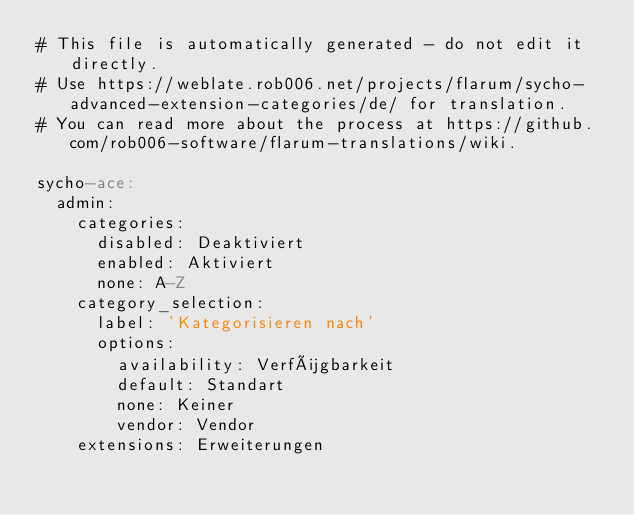<code> <loc_0><loc_0><loc_500><loc_500><_YAML_># This file is automatically generated - do not edit it directly.
# Use https://weblate.rob006.net/projects/flarum/sycho-advanced-extension-categories/de/ for translation.
# You can read more about the process at https://github.com/rob006-software/flarum-translations/wiki.

sycho-ace:
  admin:
    categories:
      disabled: Deaktiviert
      enabled: Aktiviert
      none: A-Z
    category_selection:
      label: 'Kategorisieren nach'
      options:
        availability: Verfügbarkeit
        default: Standart
        none: Keiner
        vendor: Vendor
    extensions: Erweiterungen
</code> 